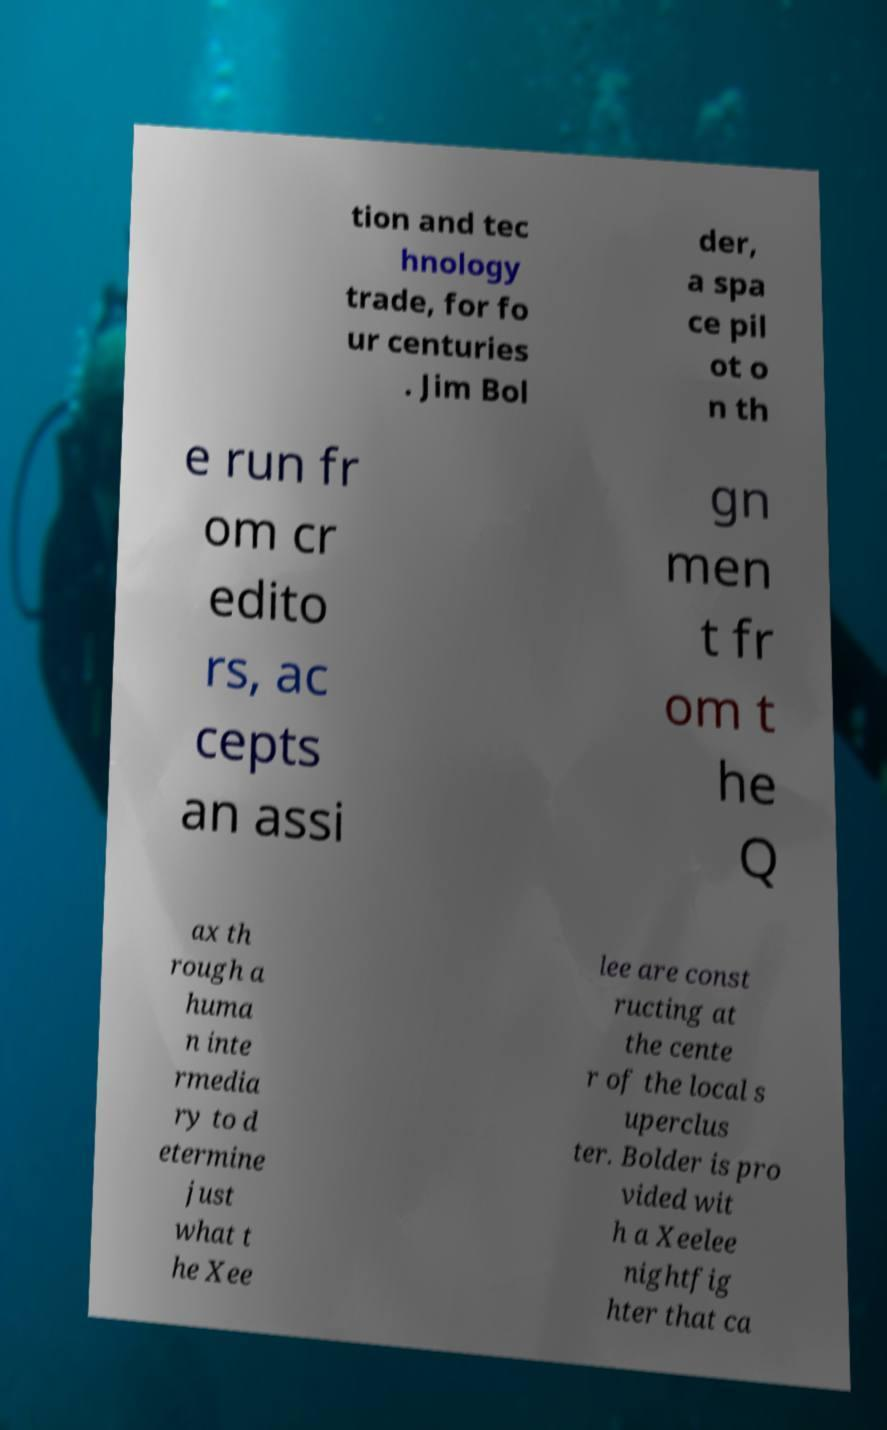What messages or text are displayed in this image? I need them in a readable, typed format. tion and tec hnology trade, for fo ur centuries . Jim Bol der, a spa ce pil ot o n th e run fr om cr edito rs, ac cepts an assi gn men t fr om t he Q ax th rough a huma n inte rmedia ry to d etermine just what t he Xee lee are const ructing at the cente r of the local s uperclus ter. Bolder is pro vided wit h a Xeelee nightfig hter that ca 